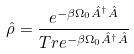Convert formula to latex. <formula><loc_0><loc_0><loc_500><loc_500>\hat { \rho } = \frac { e ^ { - \beta \Omega _ { 0 } \hat { A } ^ { \dagger } \hat { A } } } { T r e ^ { - \beta \Omega _ { 0 } \hat { A } ^ { \dagger } \hat { A } } }</formula> 